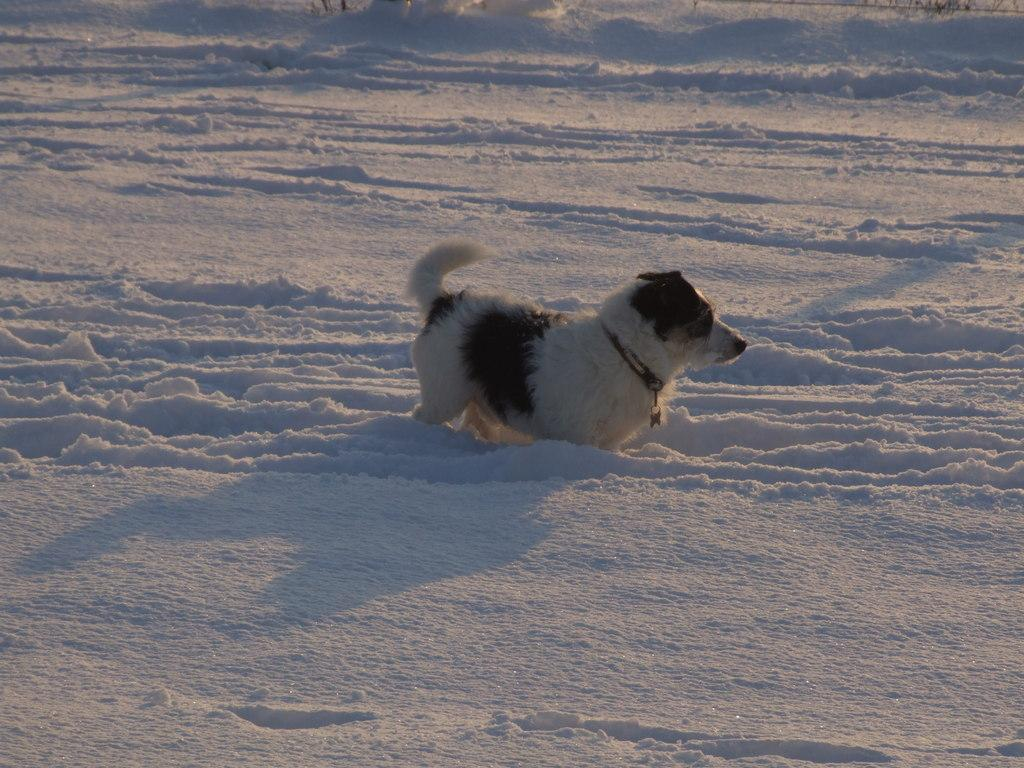What animal can be seen in the image? There is a dog in the image. What is the environment in which the dog is located? The dog is in the snow. Is there any accessory or item visible on the dog? Yes, there is a belt visible on the dog. How many fish can be seen swimming in the dog's mouth in the image? There are no fish present in the image, and the dog's mouth is not visible. 